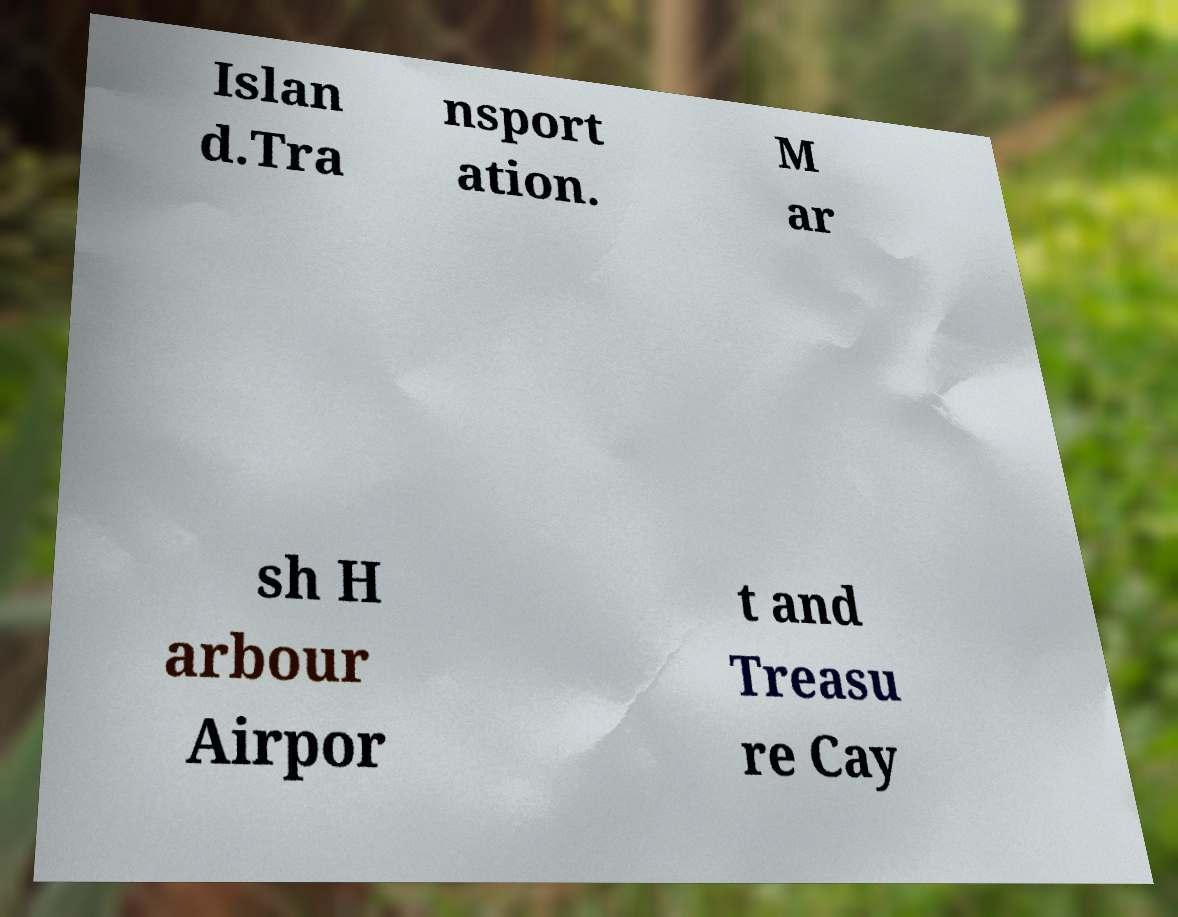There's text embedded in this image that I need extracted. Can you transcribe it verbatim? Islan d.Tra nsport ation. M ar sh H arbour Airpor t and Treasu re Cay 